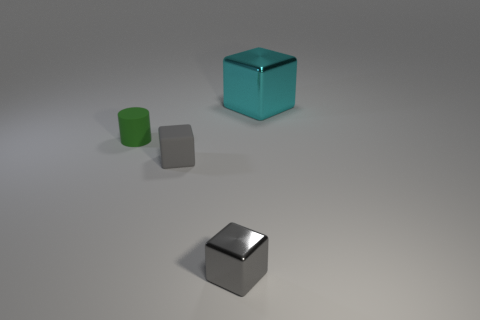Add 1 gray things. How many objects exist? 5 Subtract all cylinders. How many objects are left? 3 Subtract all blocks. Subtract all small green rubber objects. How many objects are left? 0 Add 2 small cylinders. How many small cylinders are left? 3 Add 2 tiny metal things. How many tiny metal things exist? 3 Subtract 0 blue cubes. How many objects are left? 4 